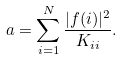Convert formula to latex. <formula><loc_0><loc_0><loc_500><loc_500>a = \sum _ { i = 1 } ^ { N } \frac { | { f } ( i ) | ^ { 2 } } { { K } _ { i i } } .</formula> 